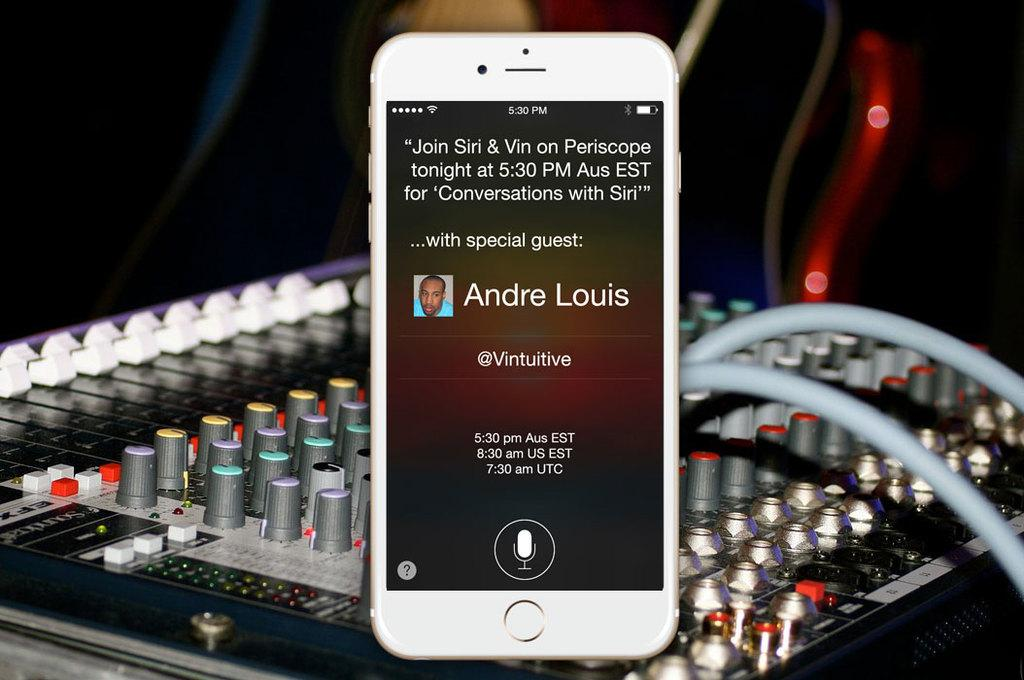<image>
Offer a succinct explanation of the picture presented. Cell phone playing a pod cast with special guest Andre Louis sitting on an amp. 